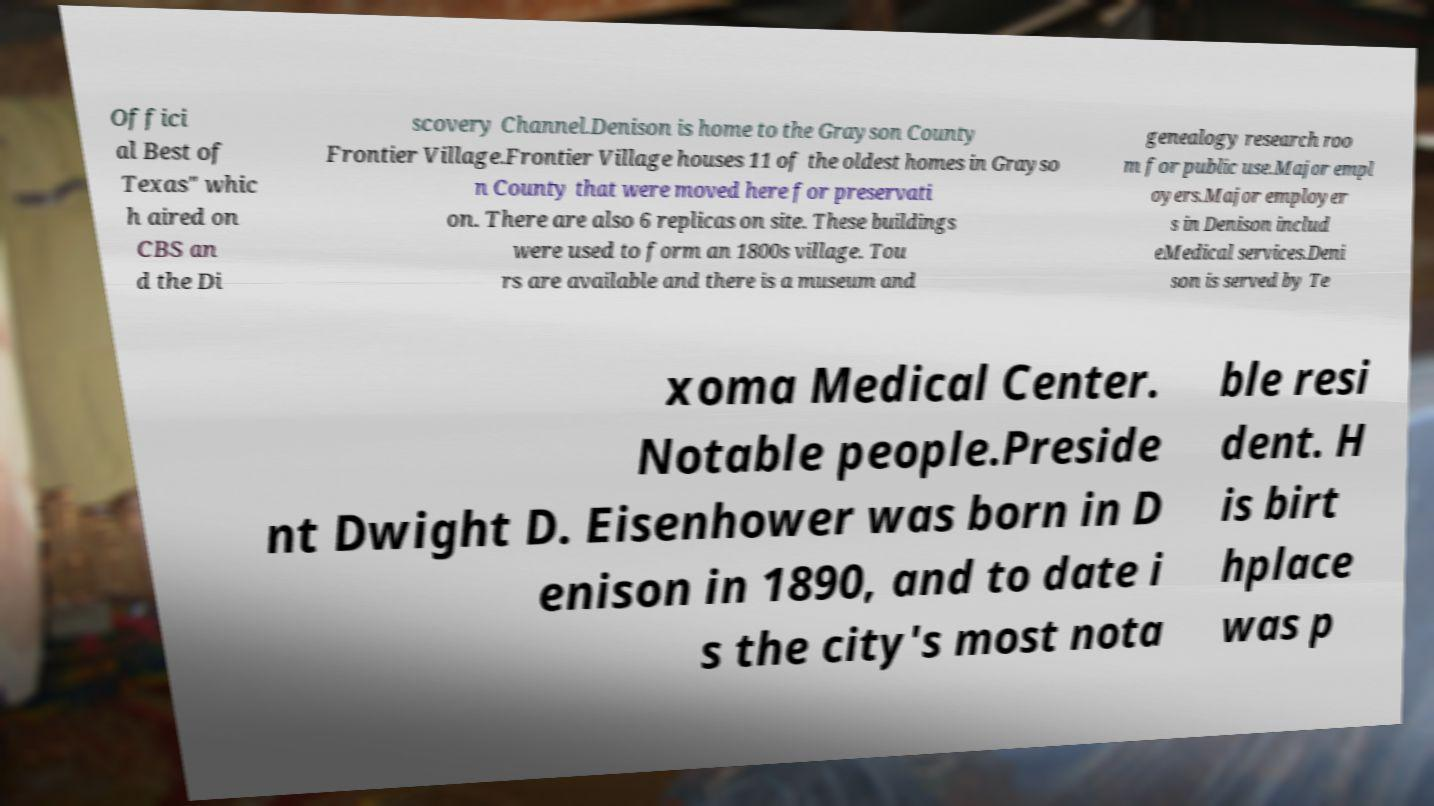For documentation purposes, I need the text within this image transcribed. Could you provide that? Offici al Best of Texas" whic h aired on CBS an d the Di scovery Channel.Denison is home to the Grayson County Frontier Village.Frontier Village houses 11 of the oldest homes in Grayso n County that were moved here for preservati on. There are also 6 replicas on site. These buildings were used to form an 1800s village. Tou rs are available and there is a museum and genealogy research roo m for public use.Major empl oyers.Major employer s in Denison includ eMedical services.Deni son is served by Te xoma Medical Center. Notable people.Preside nt Dwight D. Eisenhower was born in D enison in 1890, and to date i s the city's most nota ble resi dent. H is birt hplace was p 